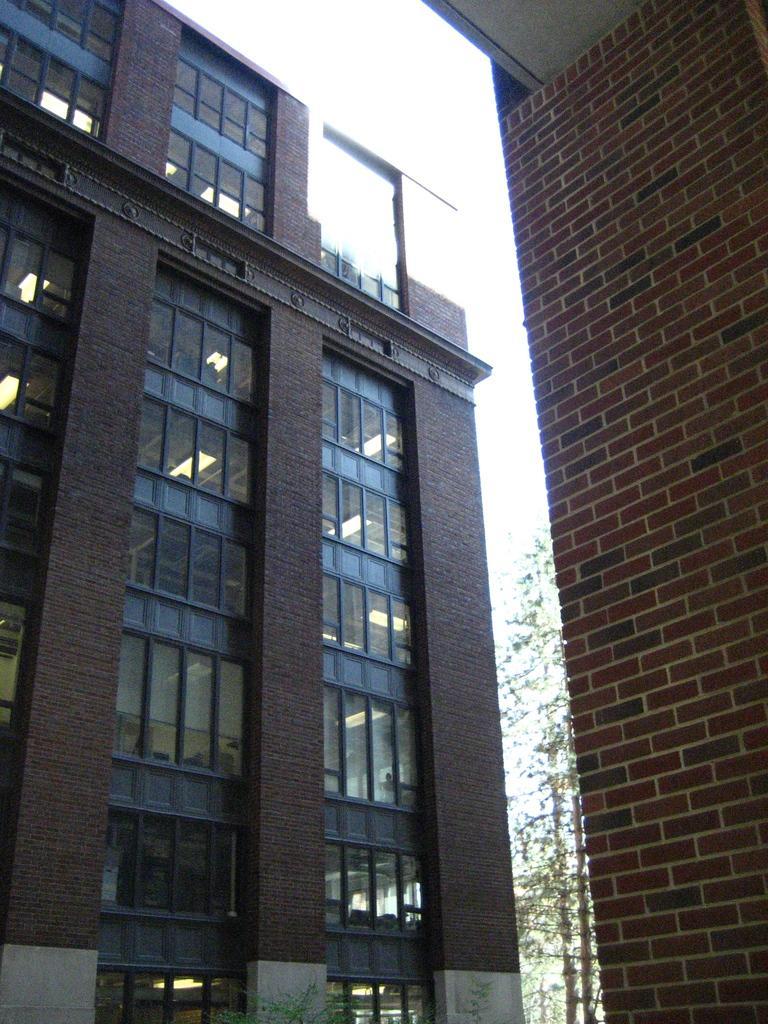Describe this image in one or two sentences. In this image we can see buildings, electric lights, plants and sky. 